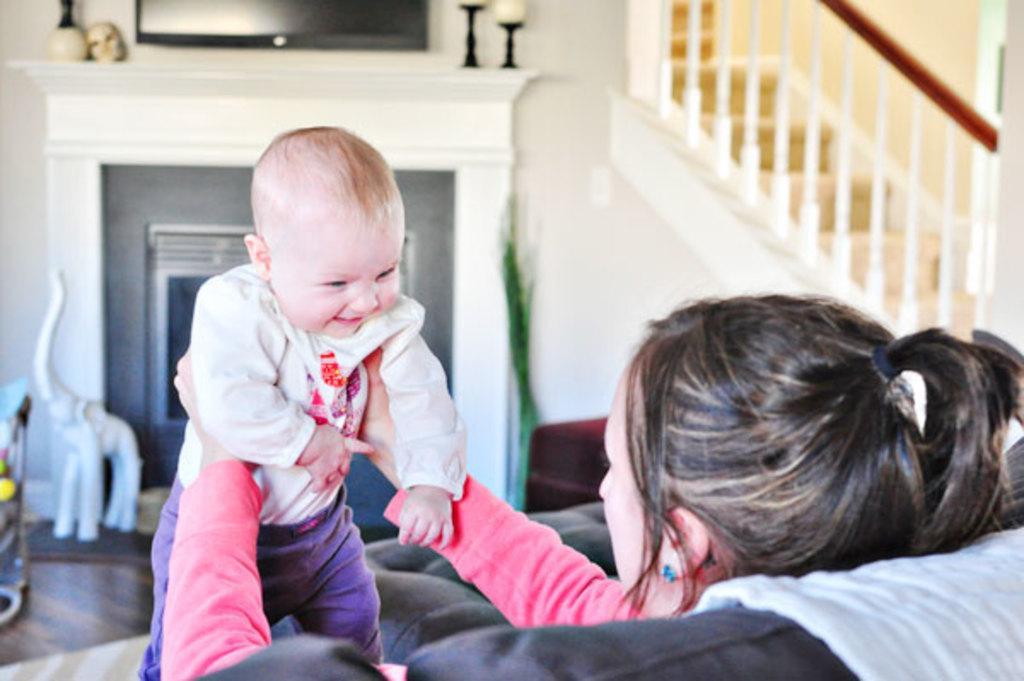In one or two sentences, can you explain what this image depicts? A woman is sitting on a couch and holding a baby. At the back there is a sculpture and candles. There are stairs and railing at the right. 